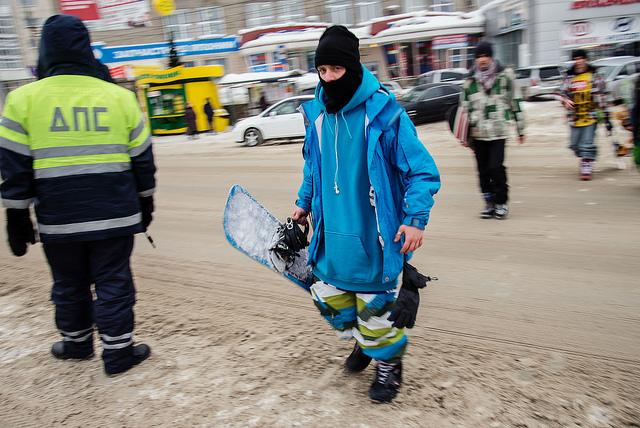What color is the man's ski mask?
Give a very brief answer. Black. How many people are in this picture?
Answer briefly. 4. What language is being used on the man's coat?
Write a very short answer. Russian. 